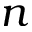Convert formula to latex. <formula><loc_0><loc_0><loc_500><loc_500>n</formula> 